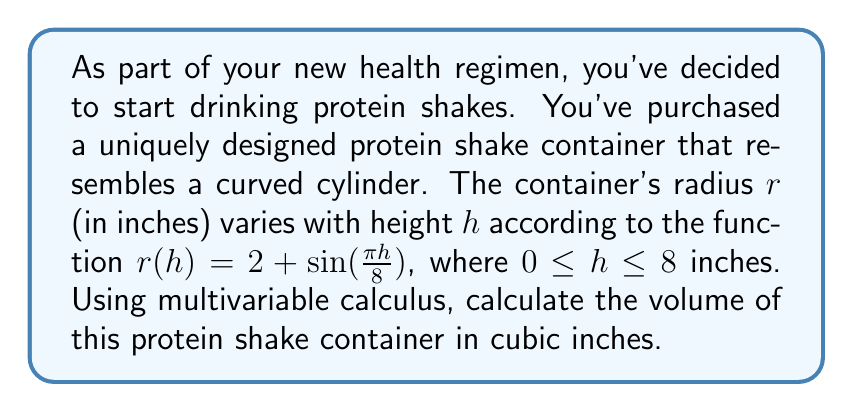Show me your answer to this math problem. To solve this problem, we'll use the method of cylindrical shells from multivariable calculus. The steps are as follows:

1) The volume of a solid of revolution can be computed using the formula:

   $$V = \int_a^b 2\pi r(h) f(h) dh$$

   where $r(h)$ is the radius function and $f(h)$ is the height function.

2) In this case, $r(h) = 2 + \sin(\frac{\pi h}{8})$ and $f(h) = h$. The limits of integration are from $a = 0$ to $b = 8$.

3) Substituting these into our volume formula:

   $$V = \int_0^8 2\pi (2 + \sin(\frac{\pi h}{8})) h dh$$

4) Expanding the integrand:

   $$V = 2\pi \int_0^8 (2h + h\sin(\frac{\pi h}{8})) dh$$

5) We can split this into two integrals:

   $$V = 2\pi [\int_0^8 2h dh + \int_0^8 h\sin(\frac{\pi h}{8}) dh]$$

6) The first integral is straightforward:

   $$\int_0^8 2h dh = h^2 \big|_0^8 = 64$$

7) For the second integral, we need to use integration by parts. Let $u = h$ and $dv = \sin(\frac{\pi h}{8}) dh$. Then $du = dh$ and $v = -\frac{8}{\pi} \cos(\frac{\pi h}{8})$.

   $$\int_0^8 h\sin(\frac{\pi h}{8}) dh = -\frac{8}{\pi} h\cos(\frac{\pi h}{8}) \big|_0^8 + \frac{8}{\pi} \int_0^8 \cos(\frac{\pi h}{8}) dh$$

8) Evaluating the first term:

   $$-\frac{8}{\pi} h\cos(\frac{\pi h}{8}) \big|_0^8 = -\frac{64}{\pi} \cos(\pi) + 0 = \frac{64}{\pi}$$

9) For the second term:

   $$\frac{8}{\pi} \int_0^8 \cos(\frac{\pi h}{8}) dh = \frac{64}{\pi^2} \sin(\frac{\pi h}{8}) \big|_0^8 = \frac{64}{\pi^2} [\sin(\pi) - \sin(0)] = 0$$

10) Combining the results from steps 6, 8, and 9:

    $$V = 2\pi [64 + \frac{64}{\pi}] = 128\pi + 128 \approx 530.14 \text{ cubic inches}$$
Answer: The volume of the protein shake container is $128\pi + 128 \approx 530.14$ cubic inches. 